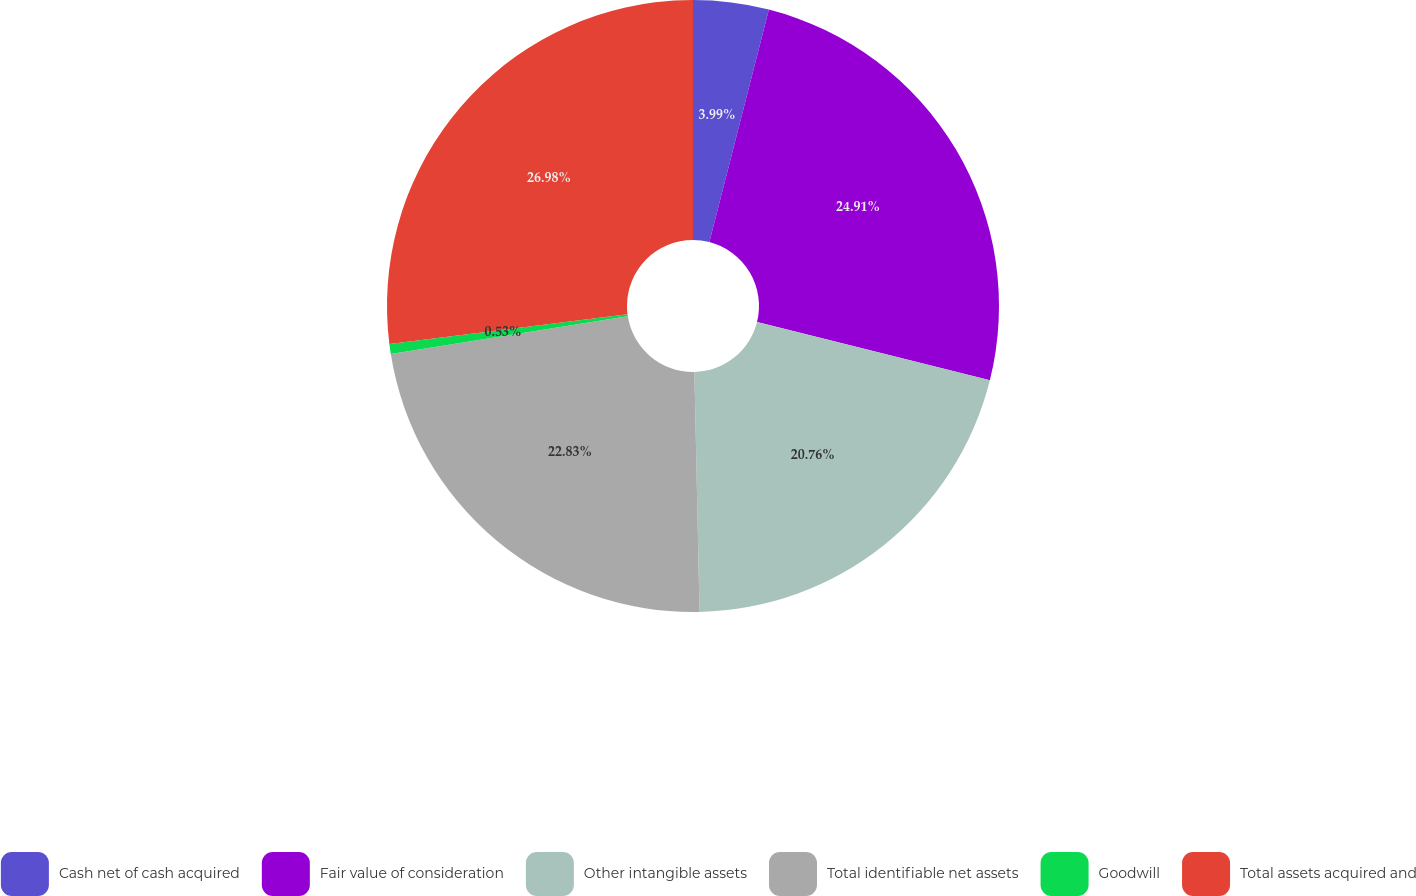Convert chart. <chart><loc_0><loc_0><loc_500><loc_500><pie_chart><fcel>Cash net of cash acquired<fcel>Fair value of consideration<fcel>Other intangible assets<fcel>Total identifiable net assets<fcel>Goodwill<fcel>Total assets acquired and<nl><fcel>3.99%<fcel>24.91%<fcel>20.76%<fcel>22.83%<fcel>0.53%<fcel>26.98%<nl></chart> 